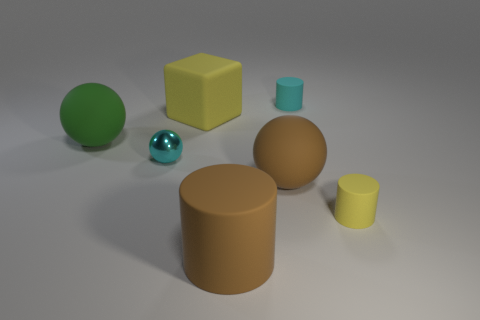What is the color of the large matte object that is the same shape as the tiny yellow rubber object? The color of the large matte object, which shares its cubic shape with the tiny yellow object, is a gentle shade of brown, similar to the color of milk chocolate or rich, loamy soil. Its subdued finish gives it an almost velvety appearance, enhancing the contrast with the small rubber object's bright, glossy yellow hue. 